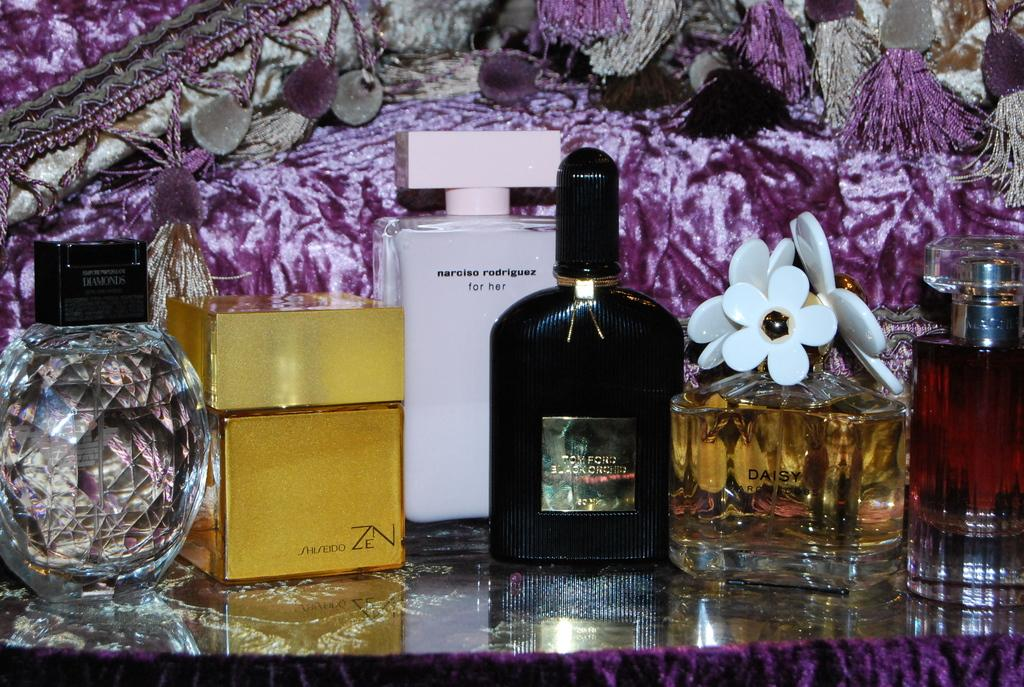What type of objects are present in the image? There are glass perfume bottles in the image. How do the perfume bottles differ from one another? The perfume bottles come in different sizes and have different colors. What else can be seen in the image besides the perfume bottles? There is a decorating cloth in the image. What month is depicted on the decorating cloth in the image? There is no month depicted on the decorating cloth in the image. Can you describe the flavor of the jelly that is being served with the perfume bottles? There is no jelly present in the image; it features glass perfume bottles and a decorating cloth. 